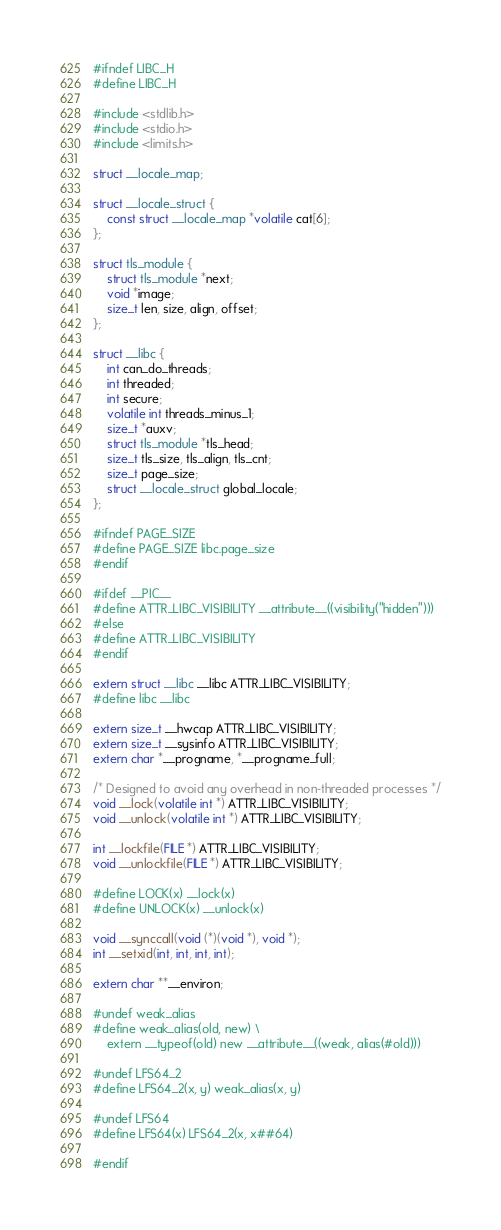<code> <loc_0><loc_0><loc_500><loc_500><_C_>#ifndef LIBC_H
#define LIBC_H

#include <stdlib.h>
#include <stdio.h>
#include <limits.h>

struct __locale_map;

struct __locale_struct {
	const struct __locale_map *volatile cat[6];
};

struct tls_module {
	struct tls_module *next;
	void *image;
	size_t len, size, align, offset;
};

struct __libc {
	int can_do_threads;
	int threaded;
	int secure;
	volatile int threads_minus_1;
	size_t *auxv;
	struct tls_module *tls_head;
	size_t tls_size, tls_align, tls_cnt;
	size_t page_size;
	struct __locale_struct global_locale;
};

#ifndef PAGE_SIZE
#define PAGE_SIZE libc.page_size
#endif

#ifdef __PIC__
#define ATTR_LIBC_VISIBILITY __attribute__((visibility("hidden")))
#else
#define ATTR_LIBC_VISIBILITY
#endif

extern struct __libc __libc ATTR_LIBC_VISIBILITY;
#define libc __libc

extern size_t __hwcap ATTR_LIBC_VISIBILITY;
extern size_t __sysinfo ATTR_LIBC_VISIBILITY;
extern char *__progname, *__progname_full;

/* Designed to avoid any overhead in non-threaded processes */
void __lock(volatile int *) ATTR_LIBC_VISIBILITY;
void __unlock(volatile int *) ATTR_LIBC_VISIBILITY;

int __lockfile(FILE *) ATTR_LIBC_VISIBILITY;
void __unlockfile(FILE *) ATTR_LIBC_VISIBILITY;

#define LOCK(x) __lock(x)
#define UNLOCK(x) __unlock(x)

void __synccall(void (*)(void *), void *);
int __setxid(int, int, int, int);

extern char **__environ;

#undef weak_alias
#define weak_alias(old, new) \
	extern __typeof(old) new __attribute__((weak, alias(#old)))

#undef LFS64_2
#define LFS64_2(x, y) weak_alias(x, y)

#undef LFS64
#define LFS64(x) LFS64_2(x, x##64)

#endif
</code> 